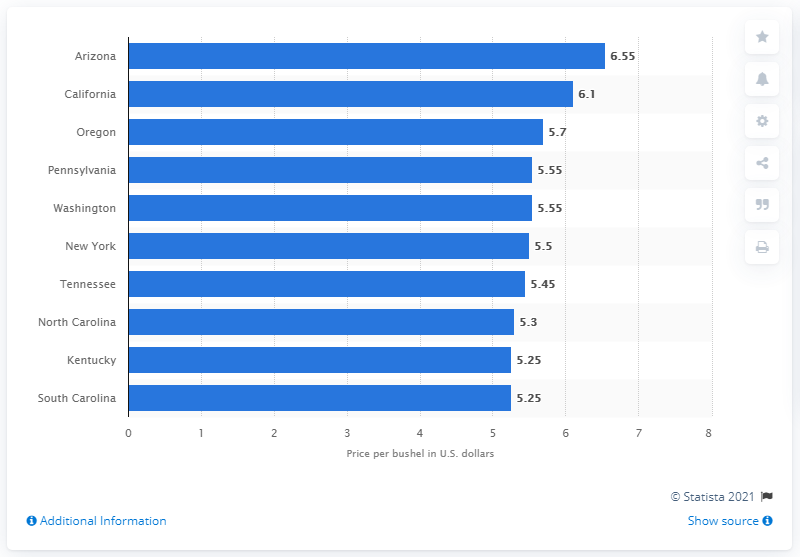Can you give me an overview of the average wheat prices shown in the image? Certainly! The image displays a bar chart with the average price per bushel of wheat for various states. Prices range from $6.55 in Arizona, which is the highest, to $5.25 in South Carolina, which is the lowest. Several states, including Pennsylvania, Washington, and New York, have the same average price of $5.55. 